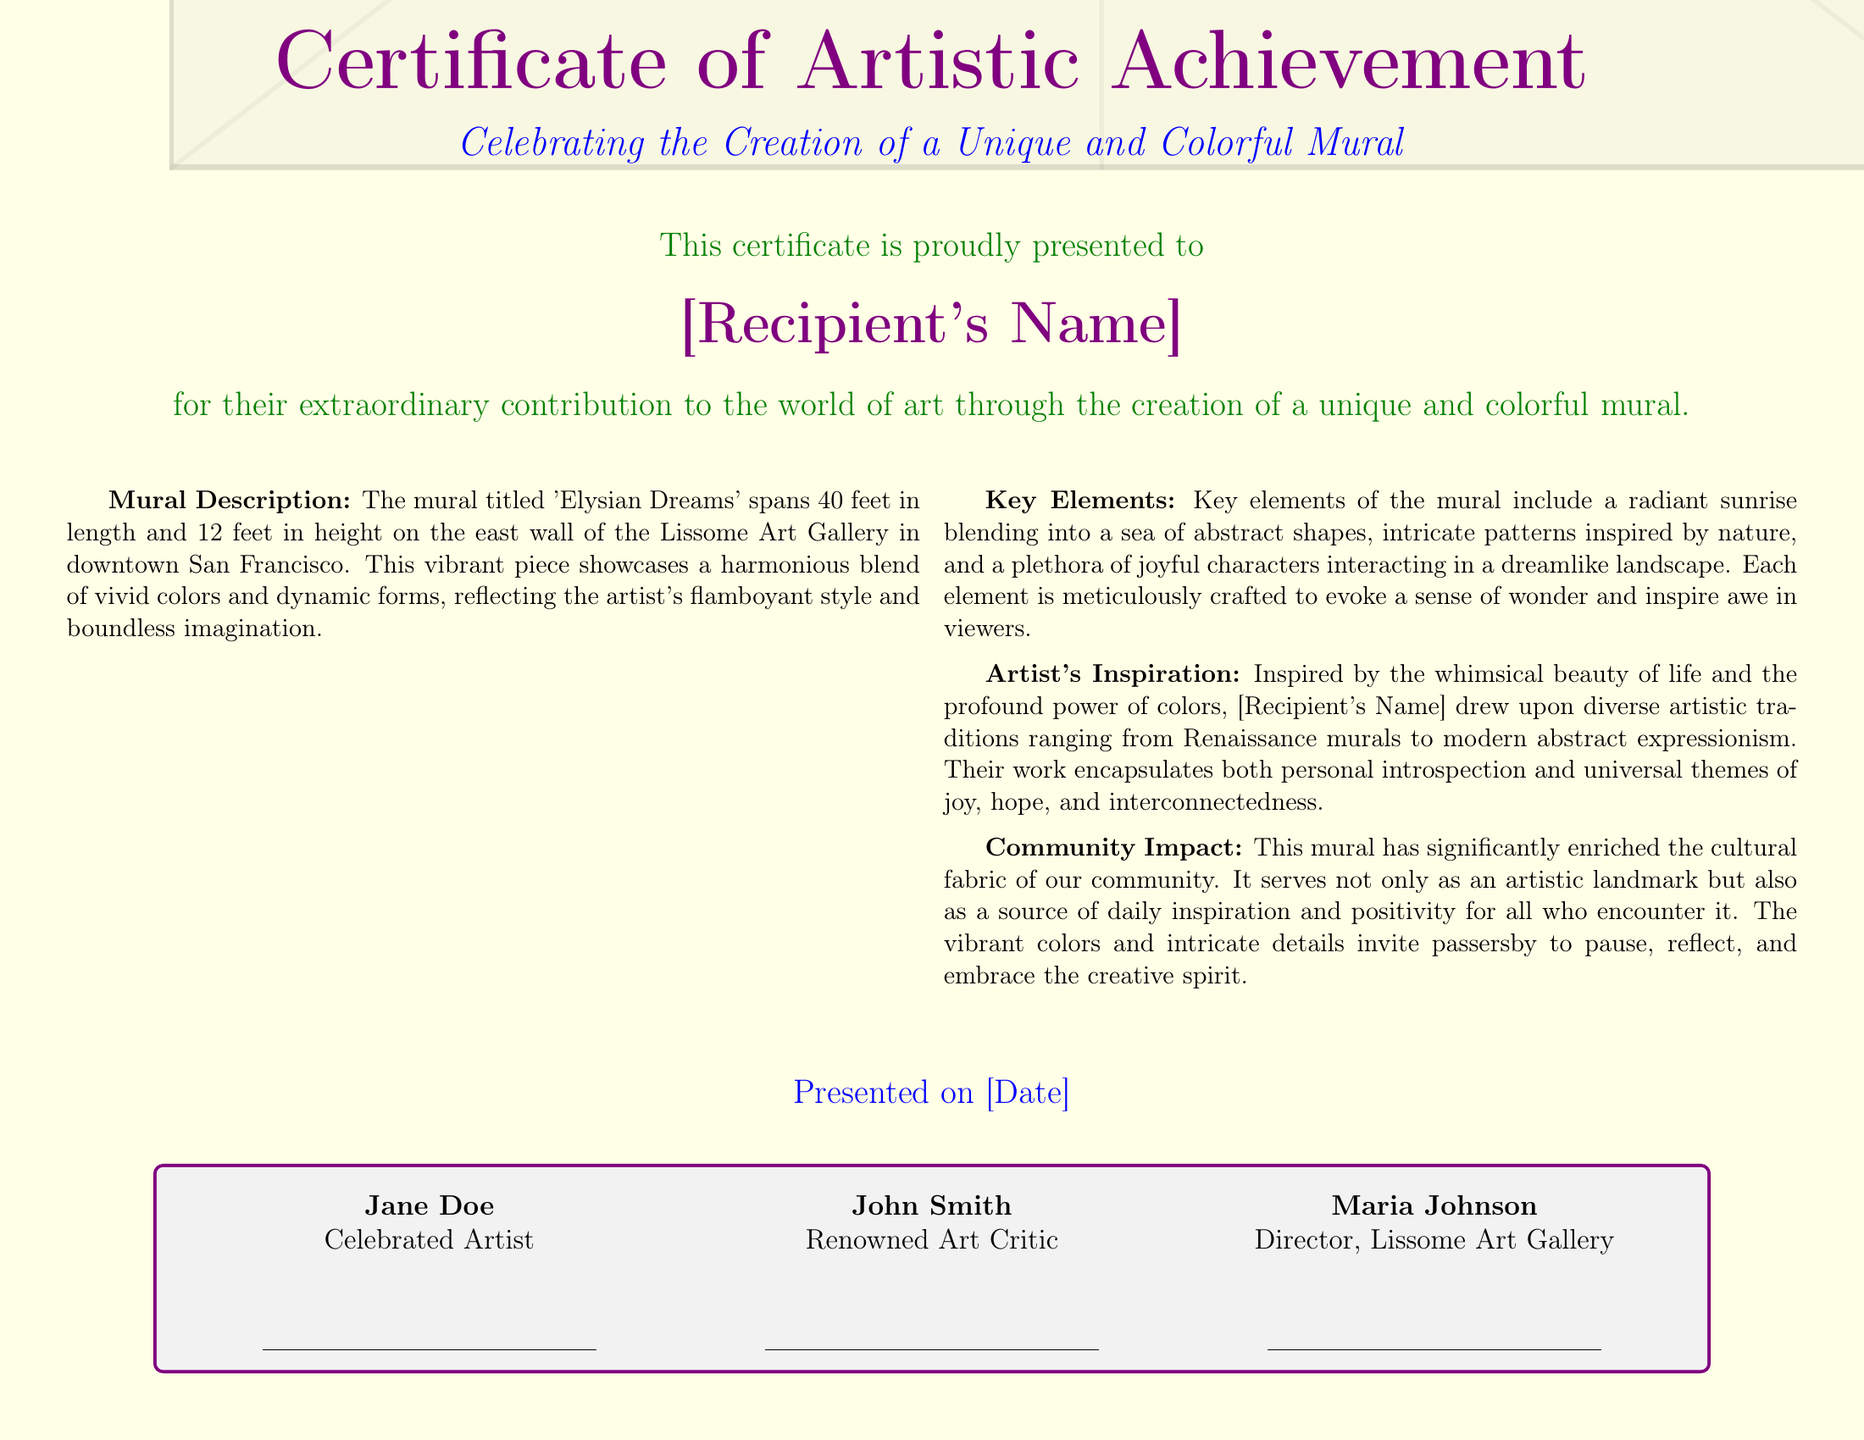What is the title of the mural? The title of the mural, as stated in the document, is 'Elysian Dreams'.
Answer: 'Elysian Dreams' What is the height of the mural? The height of the mural is specified in the document as 12 feet.
Answer: 12 feet Who is the certificate presented to? The recipient's name is noted in the document where it states, "This certificate is proudly presented to [Recipient's Name]."
Answer: [Recipient's Name] What are the key elements of the mural? The document describes the key elements including a radiant sunrise, abstract shapes, intricate patterns, and joyful characters.
Answer: Radiant sunrise, abstract shapes, intricate patterns, joyful characters What is the date of presentation? The specific date is mentioned in the document as presented on [Date].
Answer: [Date] What is the purpose of the mural according to the document? The purpose is highlighted as enriching the cultural fabric of the community, serving as an artistic landmark, and inspiring positivity.
Answer: Enriching the cultural fabric Who are the signatories on the certificate? The signatories are Jane Doe, John Smith, and Maria Johnson, as indicated in the document.
Answer: Jane Doe, John Smith, Maria Johnson What type of art does the mural combine? The document states that the mural blends diverse artistic traditions including Renaissance murals and modern abstract expressionism.
Answer: Renaissance murals and modern abstract expressionism What color is used for the award title? The document specifies that the color used for the award title is artpurple.
Answer: artpurple 